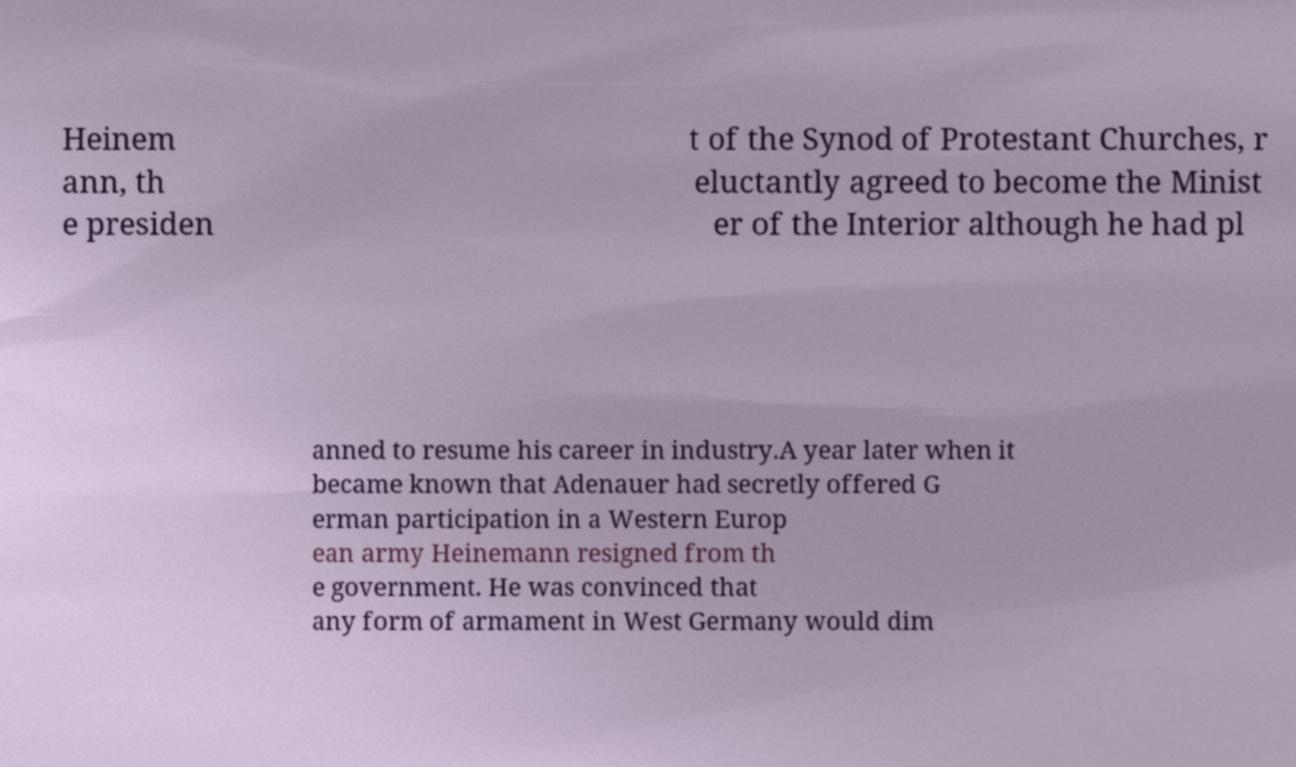Could you assist in decoding the text presented in this image and type it out clearly? Heinem ann, th e presiden t of the Synod of Protestant Churches, r eluctantly agreed to become the Minist er of the Interior although he had pl anned to resume his career in industry.A year later when it became known that Adenauer had secretly offered G erman participation in a Western Europ ean army Heinemann resigned from th e government. He was convinced that any form of armament in West Germany would dim 